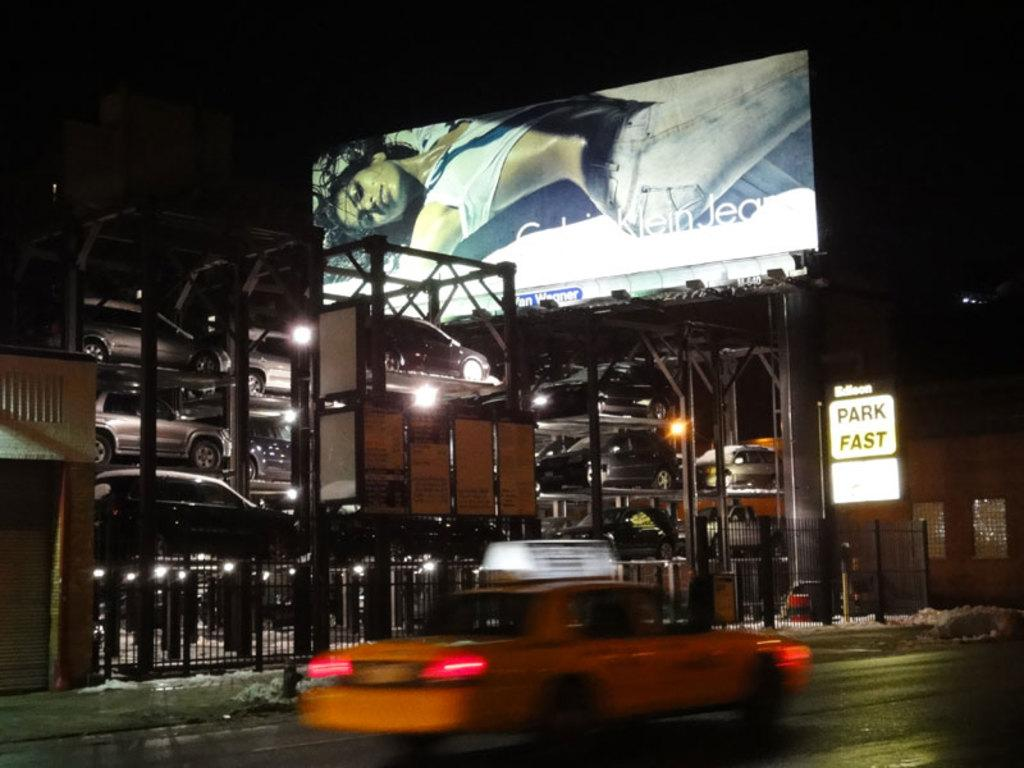<image>
Render a clear and concise summary of the photo. A street sign which on the left reads 'Park Fast.' 